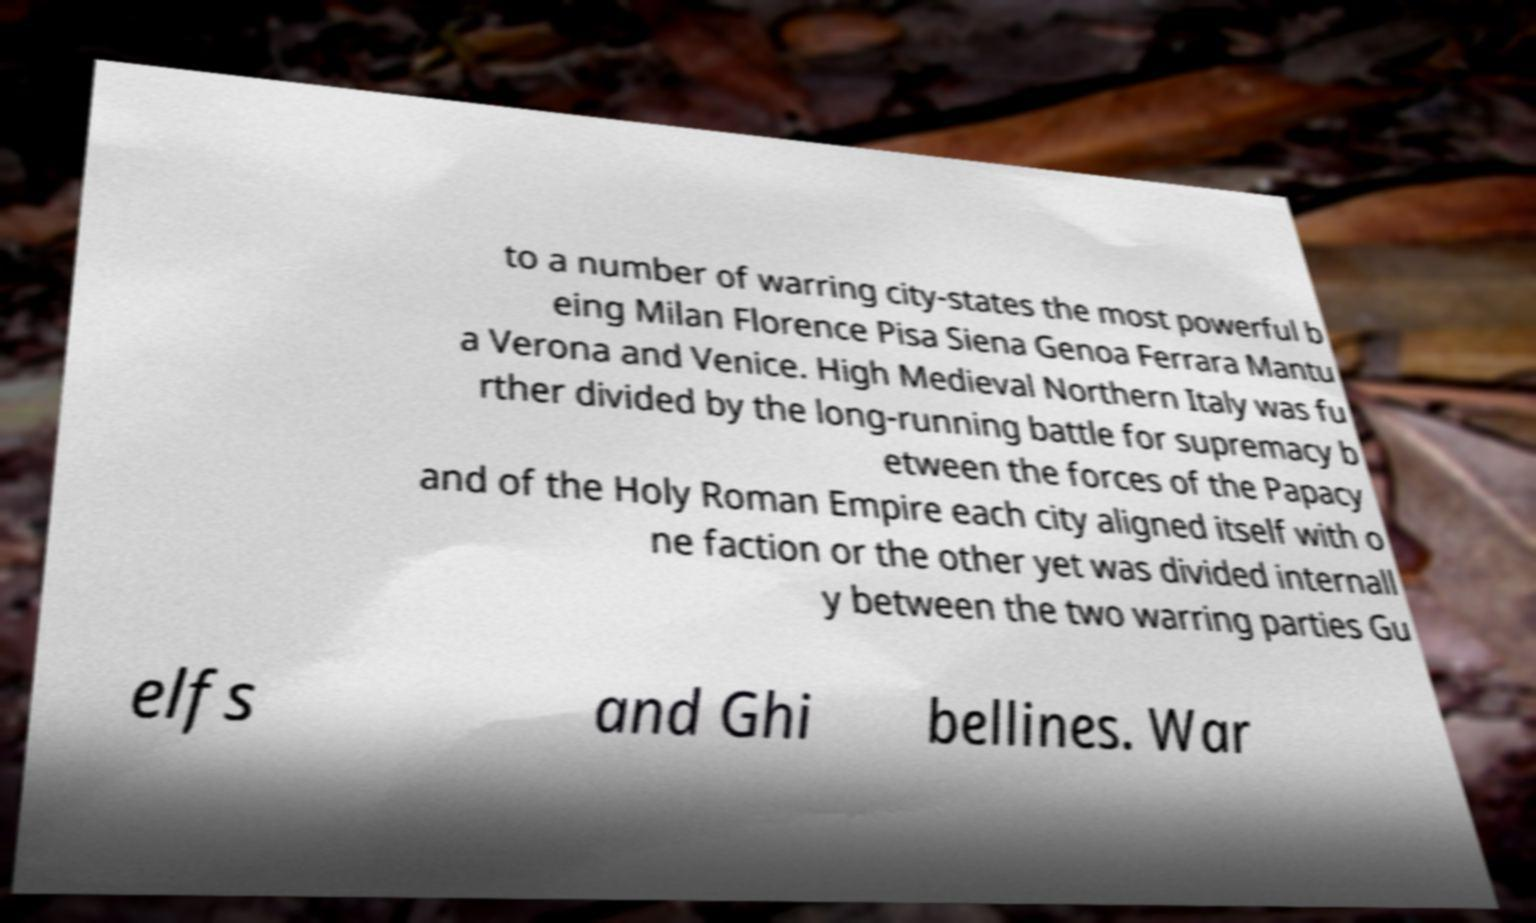I need the written content from this picture converted into text. Can you do that? to a number of warring city-states the most powerful b eing Milan Florence Pisa Siena Genoa Ferrara Mantu a Verona and Venice. High Medieval Northern Italy was fu rther divided by the long-running battle for supremacy b etween the forces of the Papacy and of the Holy Roman Empire each city aligned itself with o ne faction or the other yet was divided internall y between the two warring parties Gu elfs and Ghi bellines. War 